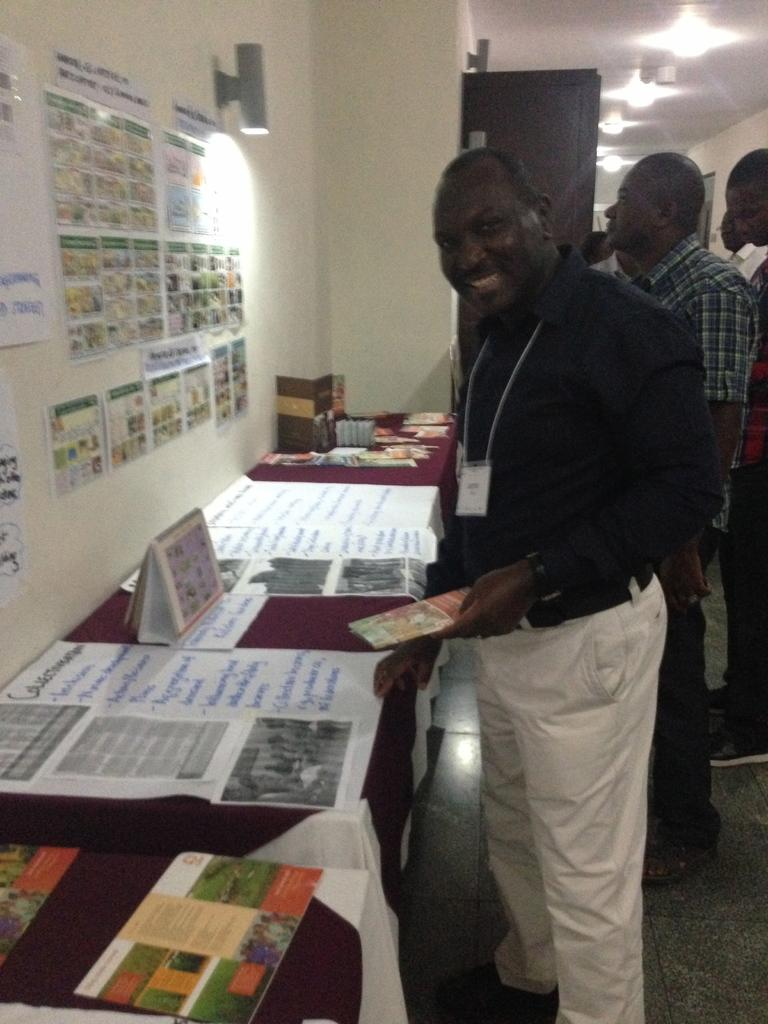What is happening in the image? There are people standing in the image. What object can be seen in the image besides the people? There is a table in the image. What is on the table? Charts and booklets are present on the table. What else can be seen in the image? There are papers on the wall. How many cows are visible in the image? There are no cows present in the image. What type of twig is being used by the people in the image? There is no twig visible in the image. 